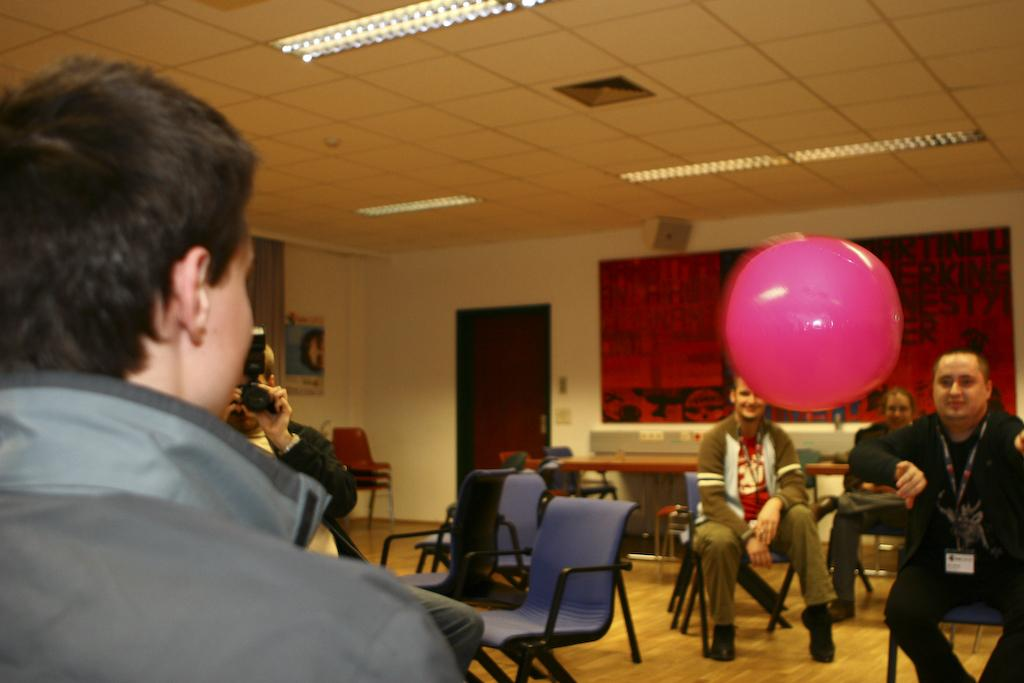What is the person in the foreground of the image doing? The person is playing with a balloon in the image. Can you describe the background of the image? In the background, there is another person, a camera, a man, chairs, a door, and a wall. What is the source of light at the top of the image? There is a light at the top of the image. What type of popcorn is being served in the image? There is no popcorn present in the image. Who is the creator of the balloon in the image? The facts provided do not mention the creator of the balloon, and it is not possible to determine this information from the image alone. 